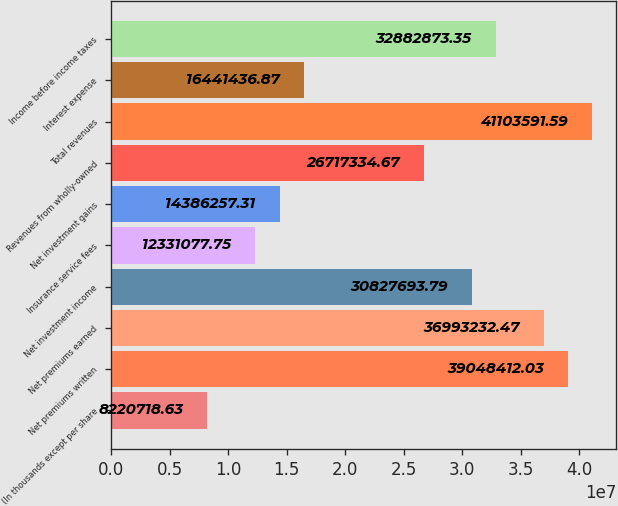Convert chart to OTSL. <chart><loc_0><loc_0><loc_500><loc_500><bar_chart><fcel>(In thousands except per share<fcel>Net premiums written<fcel>Net premiums earned<fcel>Net investment income<fcel>Insurance service fees<fcel>Net investment gains<fcel>Revenues from wholly-owned<fcel>Total revenues<fcel>Interest expense<fcel>Income before income taxes<nl><fcel>8.22072e+06<fcel>3.90484e+07<fcel>3.69932e+07<fcel>3.08277e+07<fcel>1.23311e+07<fcel>1.43863e+07<fcel>2.67173e+07<fcel>4.11036e+07<fcel>1.64414e+07<fcel>3.28829e+07<nl></chart> 